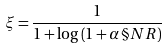<formula> <loc_0><loc_0><loc_500><loc_500>\xi = \frac { 1 } { 1 + \log \left ( 1 + \alpha \, \S N R \right ) }</formula> 